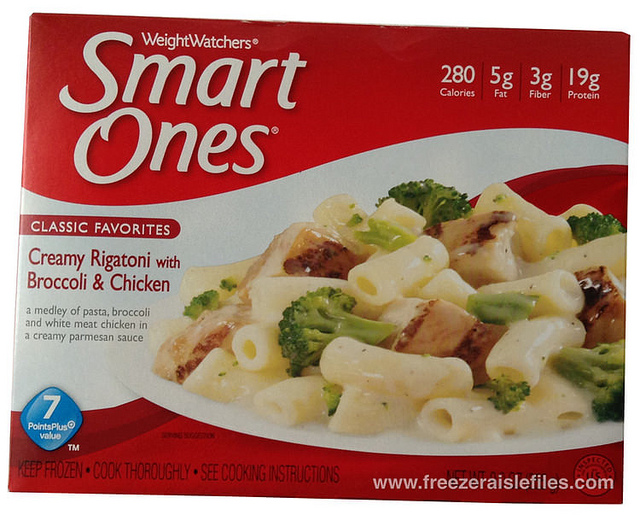Please identify all text content in this image. Weight Watchers FAVORITES CLASSIC Chicken Protein Fiber Fat Calories 19g 3g 5g 280 www.freezeraislefiles.com INSTRUCTIONS COOKING SEE THOROUGHLY COOK FROZEN KEEP TM Value PointsPlus 7 and creamy Sauce parmesan in chicken meat white of medley Pasta broccoli Broccoli with Rigatoni Creamy Ones Smart 